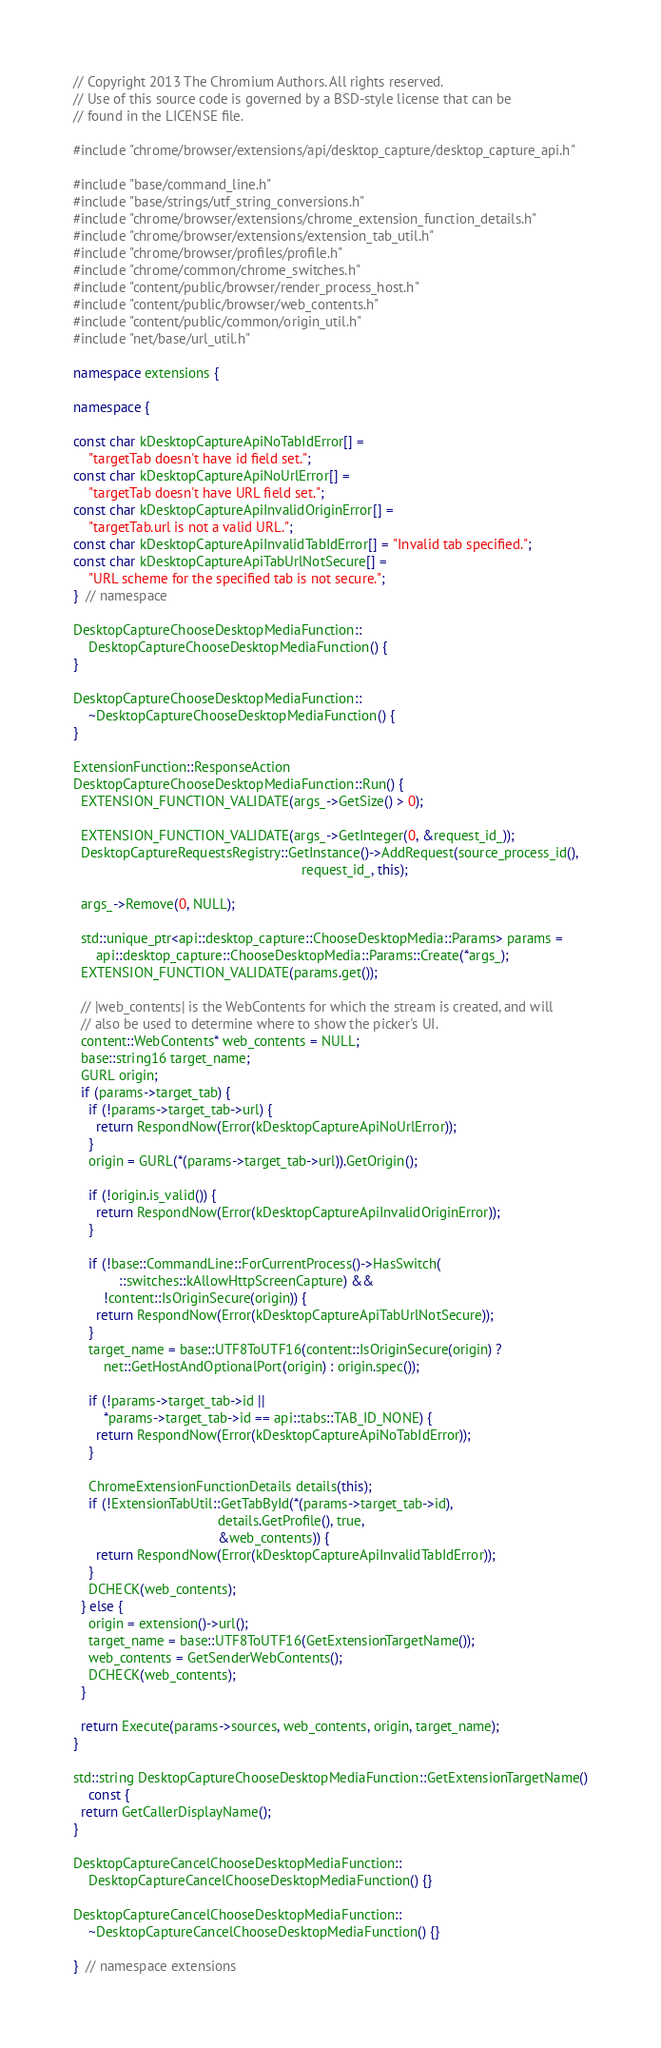<code> <loc_0><loc_0><loc_500><loc_500><_C++_>// Copyright 2013 The Chromium Authors. All rights reserved.
// Use of this source code is governed by a BSD-style license that can be
// found in the LICENSE file.

#include "chrome/browser/extensions/api/desktop_capture/desktop_capture_api.h"

#include "base/command_line.h"
#include "base/strings/utf_string_conversions.h"
#include "chrome/browser/extensions/chrome_extension_function_details.h"
#include "chrome/browser/extensions/extension_tab_util.h"
#include "chrome/browser/profiles/profile.h"
#include "chrome/common/chrome_switches.h"
#include "content/public/browser/render_process_host.h"
#include "content/public/browser/web_contents.h"
#include "content/public/common/origin_util.h"
#include "net/base/url_util.h"

namespace extensions {

namespace {

const char kDesktopCaptureApiNoTabIdError[] =
    "targetTab doesn't have id field set.";
const char kDesktopCaptureApiNoUrlError[] =
    "targetTab doesn't have URL field set.";
const char kDesktopCaptureApiInvalidOriginError[] =
    "targetTab.url is not a valid URL.";
const char kDesktopCaptureApiInvalidTabIdError[] = "Invalid tab specified.";
const char kDesktopCaptureApiTabUrlNotSecure[] =
    "URL scheme for the specified tab is not secure.";
}  // namespace

DesktopCaptureChooseDesktopMediaFunction::
    DesktopCaptureChooseDesktopMediaFunction() {
}

DesktopCaptureChooseDesktopMediaFunction::
    ~DesktopCaptureChooseDesktopMediaFunction() {
}

ExtensionFunction::ResponseAction
DesktopCaptureChooseDesktopMediaFunction::Run() {
  EXTENSION_FUNCTION_VALIDATE(args_->GetSize() > 0);

  EXTENSION_FUNCTION_VALIDATE(args_->GetInteger(0, &request_id_));
  DesktopCaptureRequestsRegistry::GetInstance()->AddRequest(source_process_id(),
                                                            request_id_, this);

  args_->Remove(0, NULL);

  std::unique_ptr<api::desktop_capture::ChooseDesktopMedia::Params> params =
      api::desktop_capture::ChooseDesktopMedia::Params::Create(*args_);
  EXTENSION_FUNCTION_VALIDATE(params.get());

  // |web_contents| is the WebContents for which the stream is created, and will
  // also be used to determine where to show the picker's UI.
  content::WebContents* web_contents = NULL;
  base::string16 target_name;
  GURL origin;
  if (params->target_tab) {
    if (!params->target_tab->url) {
      return RespondNow(Error(kDesktopCaptureApiNoUrlError));
    }
    origin = GURL(*(params->target_tab->url)).GetOrigin();

    if (!origin.is_valid()) {
      return RespondNow(Error(kDesktopCaptureApiInvalidOriginError));
    }

    if (!base::CommandLine::ForCurrentProcess()->HasSwitch(
            ::switches::kAllowHttpScreenCapture) &&
        !content::IsOriginSecure(origin)) {
      return RespondNow(Error(kDesktopCaptureApiTabUrlNotSecure));
    }
    target_name = base::UTF8ToUTF16(content::IsOriginSecure(origin) ?
        net::GetHostAndOptionalPort(origin) : origin.spec());

    if (!params->target_tab->id ||
        *params->target_tab->id == api::tabs::TAB_ID_NONE) {
      return RespondNow(Error(kDesktopCaptureApiNoTabIdError));
    }

    ChromeExtensionFunctionDetails details(this);
    if (!ExtensionTabUtil::GetTabById(*(params->target_tab->id),
                                      details.GetProfile(), true,
                                      &web_contents)) {
      return RespondNow(Error(kDesktopCaptureApiInvalidTabIdError));
    }
    DCHECK(web_contents);
  } else {
    origin = extension()->url();
    target_name = base::UTF8ToUTF16(GetExtensionTargetName());
    web_contents = GetSenderWebContents();
    DCHECK(web_contents);
  }

  return Execute(params->sources, web_contents, origin, target_name);
}

std::string DesktopCaptureChooseDesktopMediaFunction::GetExtensionTargetName()
    const {
  return GetCallerDisplayName();
}

DesktopCaptureCancelChooseDesktopMediaFunction::
    DesktopCaptureCancelChooseDesktopMediaFunction() {}

DesktopCaptureCancelChooseDesktopMediaFunction::
    ~DesktopCaptureCancelChooseDesktopMediaFunction() {}

}  // namespace extensions
</code> 